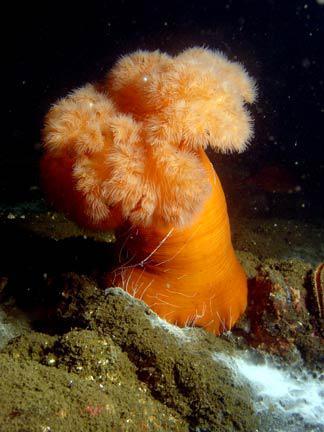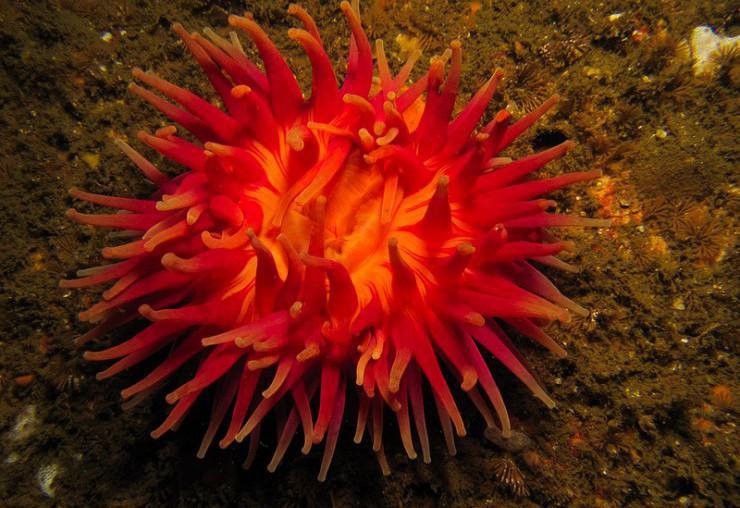The first image is the image on the left, the second image is the image on the right. Considering the images on both sides, is "In at least one image from an aerial  view you can see a circle orange corral with at  least 20 arms." valid? Answer yes or no. Yes. The first image is the image on the left, the second image is the image on the right. Given the left and right images, does the statement "The left image shows a side view of an anemone with an orange stalk and orange tendrils, and the right image shows a rounded orange anemone with no stalk." hold true? Answer yes or no. Yes. 